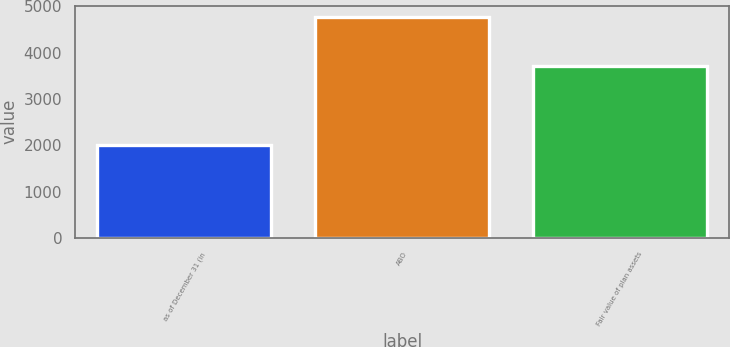Convert chart to OTSL. <chart><loc_0><loc_0><loc_500><loc_500><bar_chart><fcel>as of December 31 (in<fcel>ABO<fcel>Fair value of plan assets<nl><fcel>2013<fcel>4780<fcel>3710<nl></chart> 